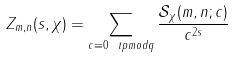<formula> <loc_0><loc_0><loc_500><loc_500>Z _ { m , n } ( s , \chi ) = \sum _ { c \equiv 0 \ t p m o d { q } } \frac { \mathcal { S } _ { \chi } ( m , n ; c ) } { c ^ { 2 s } }</formula> 